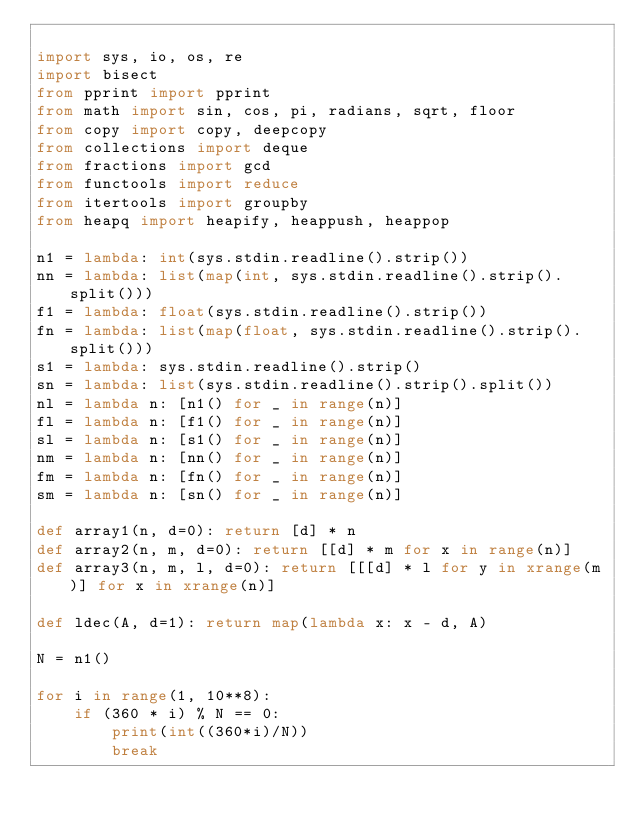Convert code to text. <code><loc_0><loc_0><loc_500><loc_500><_Python_>
import sys, io, os, re
import bisect
from pprint import pprint
from math import sin, cos, pi, radians, sqrt, floor
from copy import copy, deepcopy
from collections import deque
from fractions import gcd
from functools import reduce
from itertools import groupby
from heapq import heapify, heappush, heappop

n1 = lambda: int(sys.stdin.readline().strip())
nn = lambda: list(map(int, sys.stdin.readline().strip().split()))
f1 = lambda: float(sys.stdin.readline().strip())
fn = lambda: list(map(float, sys.stdin.readline().strip().split()))
s1 = lambda: sys.stdin.readline().strip()
sn = lambda: list(sys.stdin.readline().strip().split())
nl = lambda n: [n1() for _ in range(n)]
fl = lambda n: [f1() for _ in range(n)]
sl = lambda n: [s1() for _ in range(n)]
nm = lambda n: [nn() for _ in range(n)]
fm = lambda n: [fn() for _ in range(n)]
sm = lambda n: [sn() for _ in range(n)]

def array1(n, d=0): return [d] * n
def array2(n, m, d=0): return [[d] * m for x in range(n)]
def array3(n, m, l, d=0): return [[[d] * l for y in xrange(m)] for x in xrange(n)]

def ldec(A, d=1): return map(lambda x: x - d, A)

N = n1()

for i in range(1, 10**8):
    if (360 * i) % N == 0: 
        print(int((360*i)/N))
        break        
</code> 